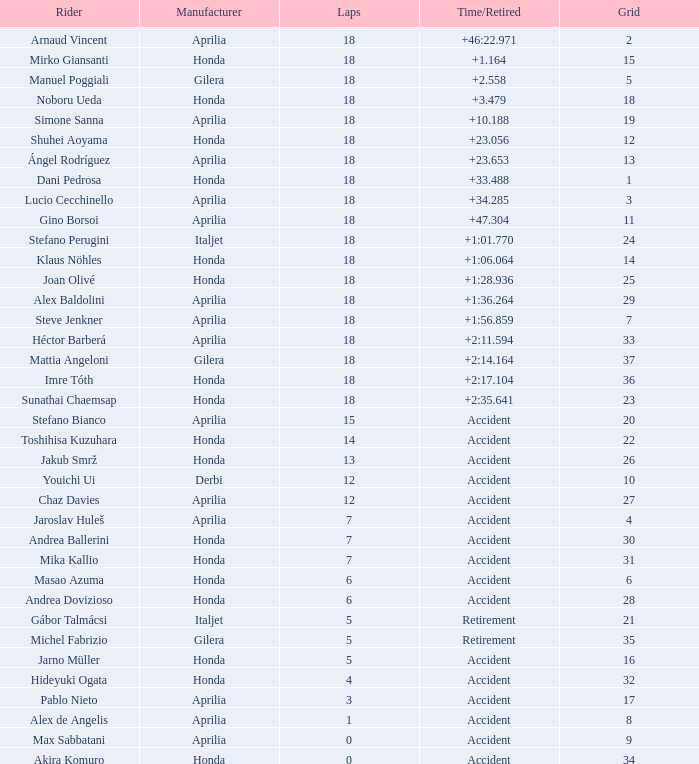Who is the rider with less than 15 laps, more than 32 grids, and an accident time/retired? Akira Komuro. 